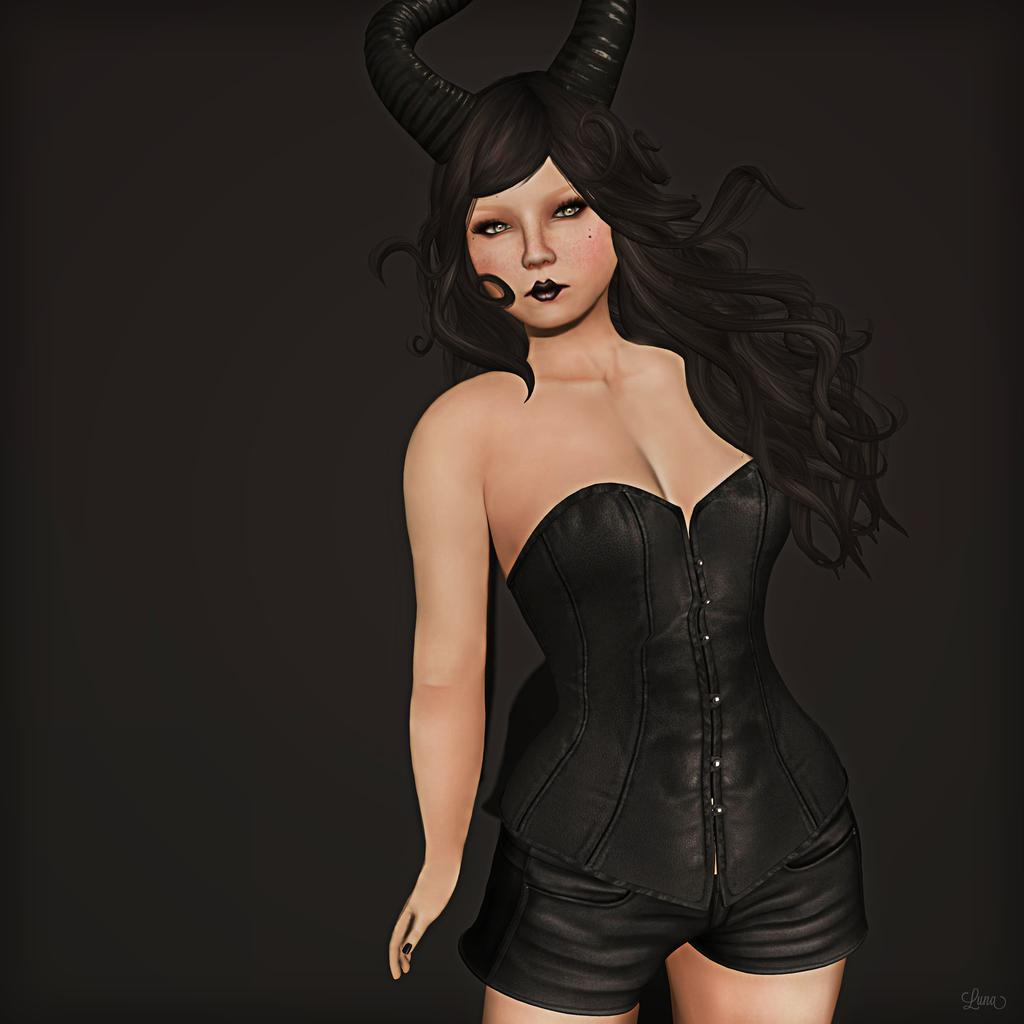What type of image is being described? The image is graphical in nature. How many carriages are present in the image? There are no carriages present in the image, as it is graphical in nature and does not depict real-world objects or scenes. 